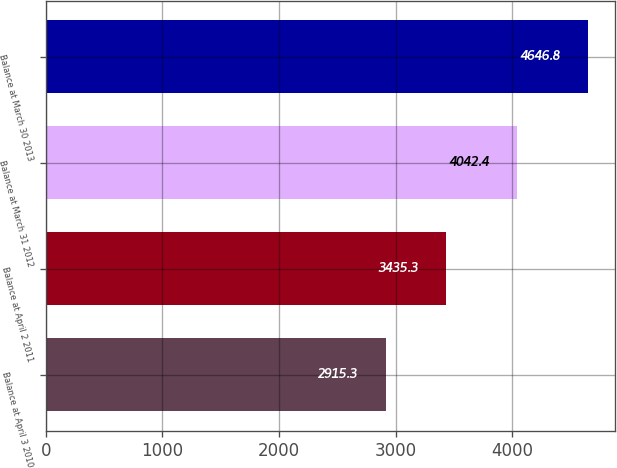Convert chart. <chart><loc_0><loc_0><loc_500><loc_500><bar_chart><fcel>Balance at April 3 2010<fcel>Balance at April 2 2011<fcel>Balance at March 31 2012<fcel>Balance at March 30 2013<nl><fcel>2915.3<fcel>3435.3<fcel>4042.4<fcel>4646.8<nl></chart> 